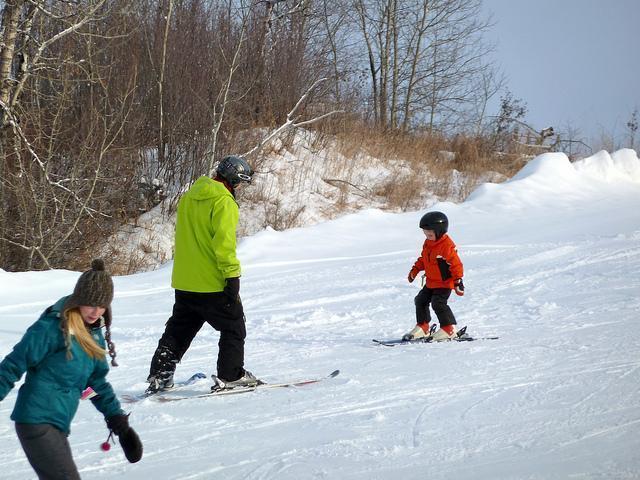How many people are wearing helmets in this picture?
Give a very brief answer. 2. How many people in this photo have long hair?
Give a very brief answer. 1. How many people are in the picture?
Give a very brief answer. 3. 